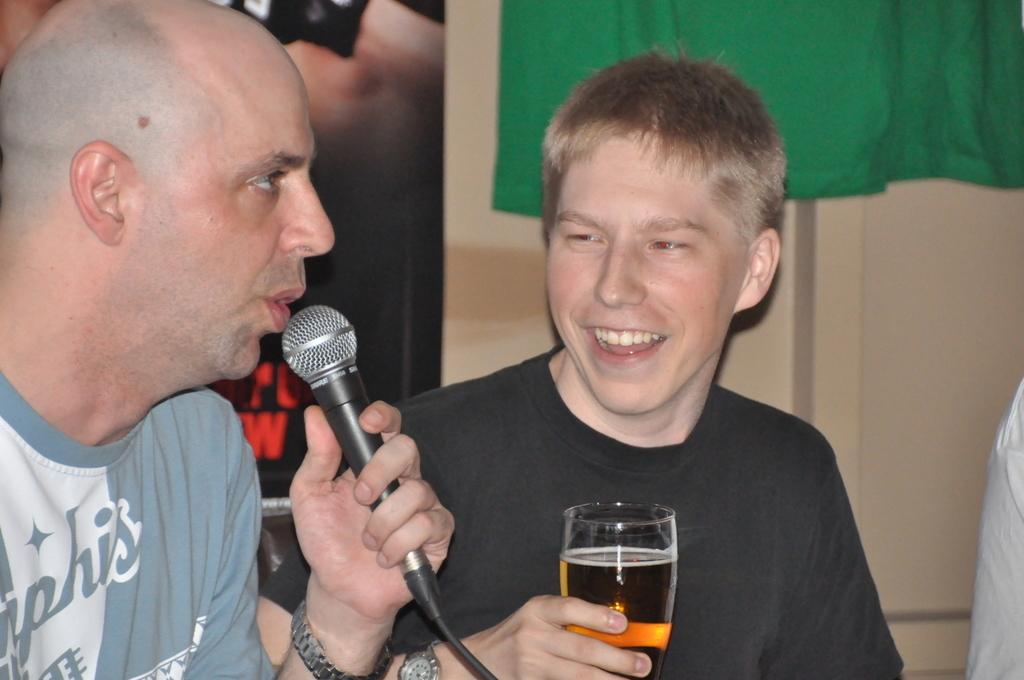What is the man in the image doing? The man is sitting and holding a mic in his hand. Can you describe the other man in the image? The second man is also in the image, and he is holding a wine glass in his hand. What type of bubble can be seen floating near the man holding the mic? There is no bubble present in the image. 